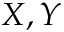<formula> <loc_0><loc_0><loc_500><loc_500>X , Y</formula> 